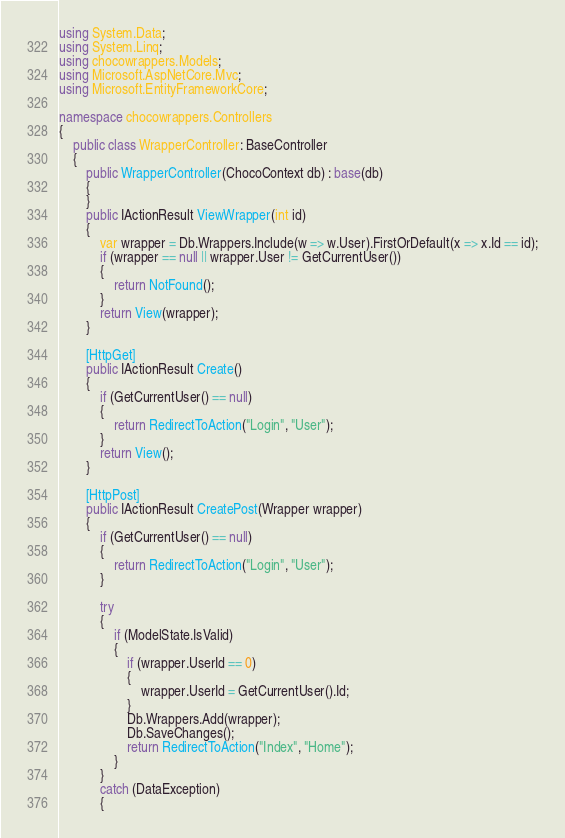<code> <loc_0><loc_0><loc_500><loc_500><_C#_>using System.Data;
using System.Linq;
using chocowrappers.Models;
using Microsoft.AspNetCore.Mvc;
using Microsoft.EntityFrameworkCore;

namespace chocowrappers.Controllers
{
    public class WrapperController: BaseController
    {
        public WrapperController(ChocoContext db) : base(db)
        {
        }
        public IActionResult ViewWrapper(int id)
        {
            var wrapper = Db.Wrappers.Include(w => w.User).FirstOrDefault(x => x.Id == id);
            if (wrapper == null || wrapper.User != GetCurrentUser())
            {
                return NotFound();
            }
            return View(wrapper);
        }

        [HttpGet]
        public IActionResult Create()
        {
            if (GetCurrentUser() == null)
            {
                return RedirectToAction("Login", "User");
            }
            return View();
        }
        
        [HttpPost]
        public IActionResult CreatePost(Wrapper wrapper)
        {
            if (GetCurrentUser() == null)
            {
                return RedirectToAction("Login", "User");
            }
            
            try
            {
                if (ModelState.IsValid)
                {
                    if (wrapper.UserId == 0)
                    {
                        wrapper.UserId = GetCurrentUser().Id;
                    }
                    Db.Wrappers.Add(wrapper);
                    Db.SaveChanges();
                    return RedirectToAction("Index", "Home");
                }
            }
            catch (DataException)
            {</code> 